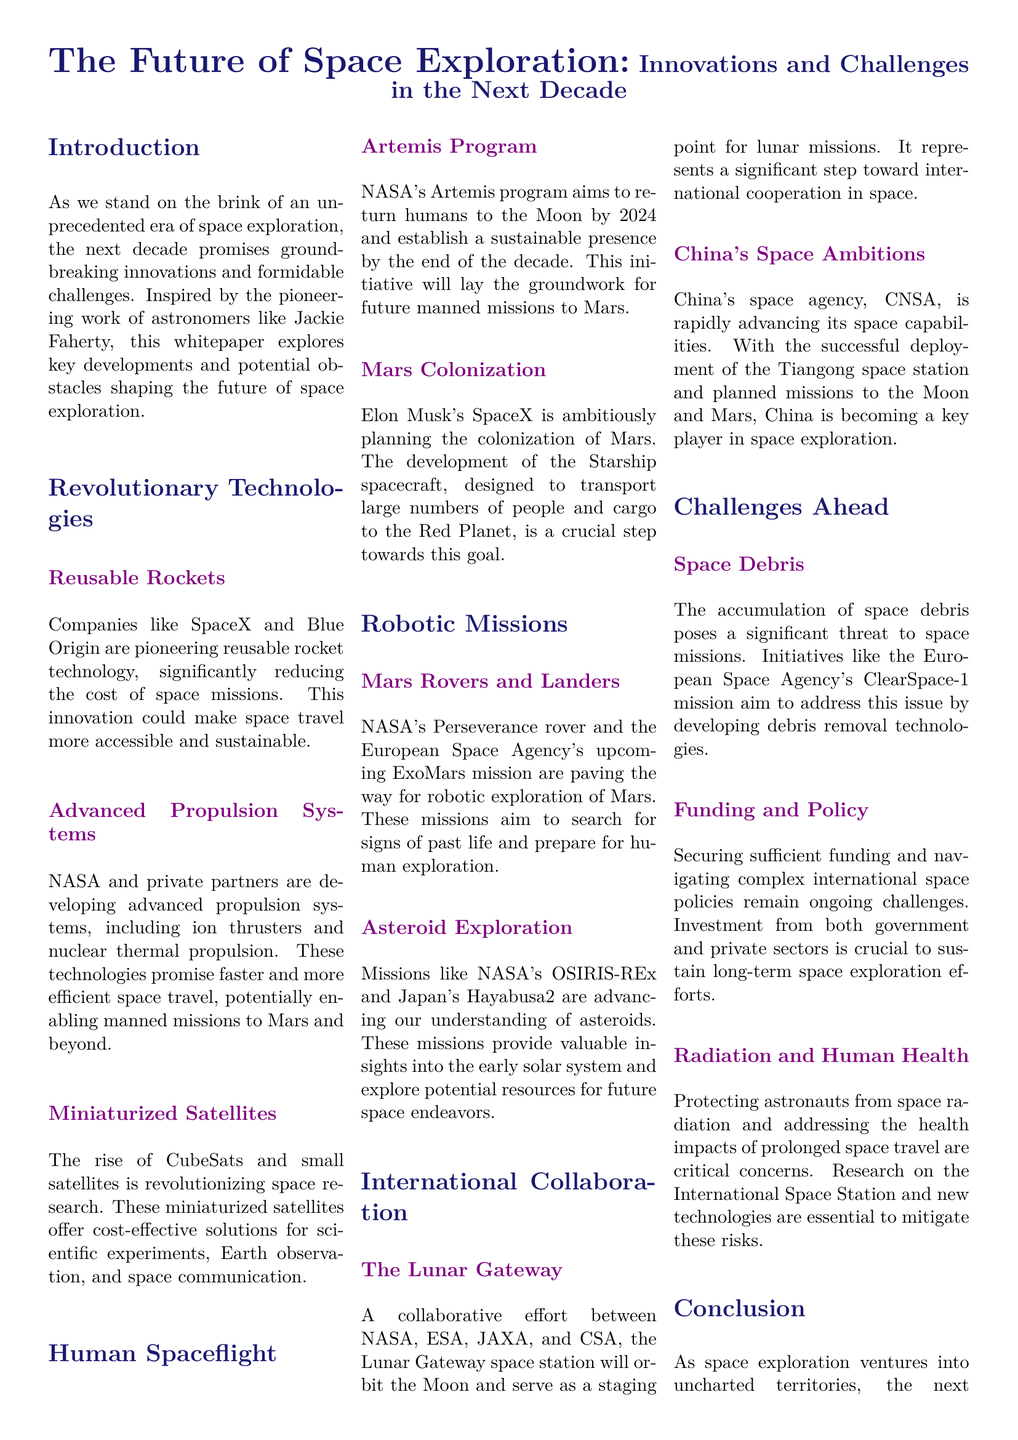What is the title of the whitepaper? The title of the whitepaper is prominently displayed at the beginning, outlining its subject.
Answer: The Future of Space Exploration: Innovations and Challenges in the Next Decade Which company is mentioned for its reusable rocket technology? The document highlights companies that are significant in the field of reusable rocket technology, specifically mentioning key players.
Answer: SpaceX What major program aims to return humans to the Moon? This program is highlighted as a significant initiative for human spaceflight in the document.
Answer: Artemis Program What technology is associated with the colonization of Mars? The whitepaper discusses specific vehicles designed for Mars colonization, connecting them to a noted company's efforts.
Answer: Starship Which space agency is involved in the Lunar Gateway collaboration? The document outlines collaborative efforts in space exploration, naming several space agencies contributing to this initiative.
Answer: NASA What is a major challenge mentioned in the document regarding human space travel? The paper discusses crucial concerns surrounding human space travel, particularly related to health and safety.
Answer: Radiation How many countries are cited as key players in current space exploration? The document specifies the participation and capabilities of several countries in the field of space exploration.
Answer: Four Which mission addresses the issue of space debris? This particular mission is referenced as a proactive approach to a growing problem in space activities.
Answer: ClearSpace-1 What type of propulsion systems are being developed by NASA? The document mentions a specific category of propulsion technology that is being pursued to enhance space travel efficiency.
Answer: Advanced propulsion systems 